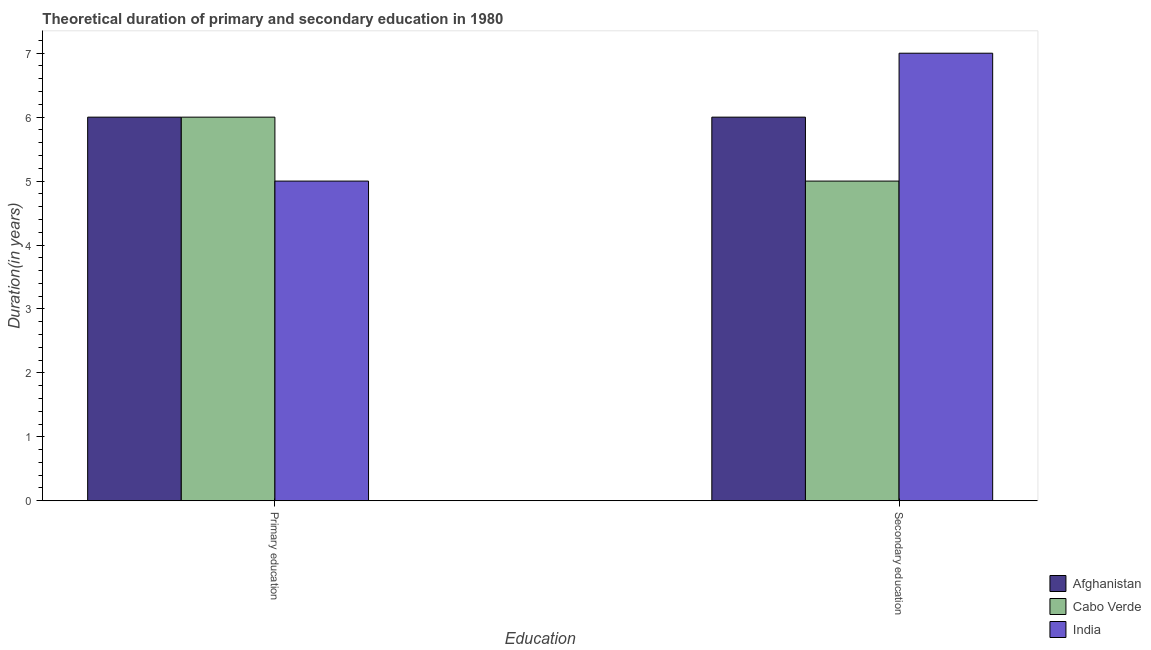How many groups of bars are there?
Your answer should be very brief. 2. Are the number of bars on each tick of the X-axis equal?
Give a very brief answer. Yes. What is the label of the 2nd group of bars from the left?
Offer a very short reply. Secondary education. What is the duration of secondary education in Afghanistan?
Provide a succinct answer. 6. Across all countries, what is the minimum duration of secondary education?
Keep it short and to the point. 5. In which country was the duration of primary education maximum?
Keep it short and to the point. Afghanistan. What is the total duration of primary education in the graph?
Your response must be concise. 17. What is the difference between the duration of primary education in Afghanistan and that in India?
Your answer should be compact. 1. What is the difference between the duration of secondary education in India and the duration of primary education in Afghanistan?
Make the answer very short. 1. What is the average duration of primary education per country?
Your response must be concise. 5.67. What is the difference between the duration of secondary education and duration of primary education in Cabo Verde?
Offer a terse response. -1. What is the ratio of the duration of secondary education in Cabo Verde to that in Afghanistan?
Ensure brevity in your answer.  0.83. Is the duration of secondary education in Afghanistan less than that in Cabo Verde?
Your answer should be very brief. No. What does the 2nd bar from the left in Primary education represents?
Offer a terse response. Cabo Verde. How many bars are there?
Your response must be concise. 6. Are all the bars in the graph horizontal?
Your answer should be very brief. No. Are the values on the major ticks of Y-axis written in scientific E-notation?
Offer a terse response. No. Does the graph contain any zero values?
Offer a very short reply. No. What is the title of the graph?
Offer a terse response. Theoretical duration of primary and secondary education in 1980. Does "Myanmar" appear as one of the legend labels in the graph?
Provide a short and direct response. No. What is the label or title of the X-axis?
Provide a short and direct response. Education. What is the label or title of the Y-axis?
Your answer should be very brief. Duration(in years). What is the Duration(in years) in Cabo Verde in Primary education?
Your answer should be very brief. 6. What is the Duration(in years) of India in Primary education?
Keep it short and to the point. 5. What is the Duration(in years) of Afghanistan in Secondary education?
Your response must be concise. 6. What is the Duration(in years) of Cabo Verde in Secondary education?
Offer a very short reply. 5. Across all Education, what is the minimum Duration(in years) in Cabo Verde?
Offer a terse response. 5. Across all Education, what is the minimum Duration(in years) of India?
Provide a succinct answer. 5. What is the total Duration(in years) in Afghanistan in the graph?
Provide a short and direct response. 12. What is the total Duration(in years) in Cabo Verde in the graph?
Give a very brief answer. 11. What is the total Duration(in years) in India in the graph?
Offer a very short reply. 12. What is the difference between the Duration(in years) in Afghanistan in Primary education and the Duration(in years) in Cabo Verde in Secondary education?
Your answer should be very brief. 1. What is the difference between the Duration(in years) of Cabo Verde in Primary education and the Duration(in years) of India in Secondary education?
Make the answer very short. -1. What is the average Duration(in years) of Afghanistan per Education?
Ensure brevity in your answer.  6. What is the average Duration(in years) in Cabo Verde per Education?
Your response must be concise. 5.5. What is the difference between the Duration(in years) of Afghanistan and Duration(in years) of Cabo Verde in Primary education?
Your response must be concise. 0. What is the difference between the Duration(in years) in Cabo Verde and Duration(in years) in India in Primary education?
Your answer should be very brief. 1. What is the difference between the Duration(in years) of Afghanistan and Duration(in years) of India in Secondary education?
Provide a succinct answer. -1. What is the difference between the Duration(in years) in Cabo Verde and Duration(in years) in India in Secondary education?
Ensure brevity in your answer.  -2. What is the ratio of the Duration(in years) in Afghanistan in Primary education to that in Secondary education?
Your answer should be very brief. 1. What is the ratio of the Duration(in years) in Cabo Verde in Primary education to that in Secondary education?
Give a very brief answer. 1.2. What is the ratio of the Duration(in years) in India in Primary education to that in Secondary education?
Give a very brief answer. 0.71. What is the difference between the highest and the second highest Duration(in years) of Cabo Verde?
Provide a short and direct response. 1. What is the difference between the highest and the lowest Duration(in years) in Cabo Verde?
Provide a short and direct response. 1. What is the difference between the highest and the lowest Duration(in years) in India?
Your response must be concise. 2. 